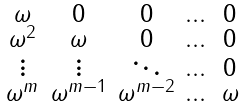<formula> <loc_0><loc_0><loc_500><loc_500>\begin{smallmatrix} \omega & 0 & 0 & \dots & 0 \\ \omega ^ { 2 } & \omega & 0 & \dots & 0 \\ \vdots & \vdots & \ddots & \dots & 0 \\ \omega ^ { m } & \omega ^ { m - 1 } & \omega ^ { m - 2 } & \dots & \omega \end{smallmatrix}</formula> 